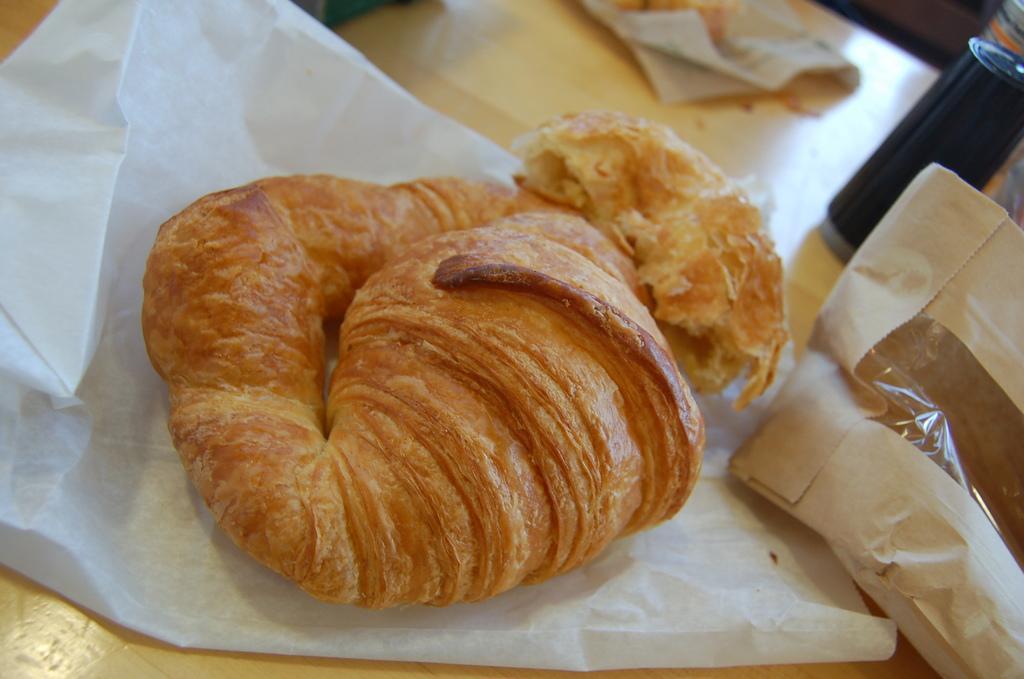How would you summarize this image in a sentence or two? In this image there are food items on the papers, packet and two objects on the table. 